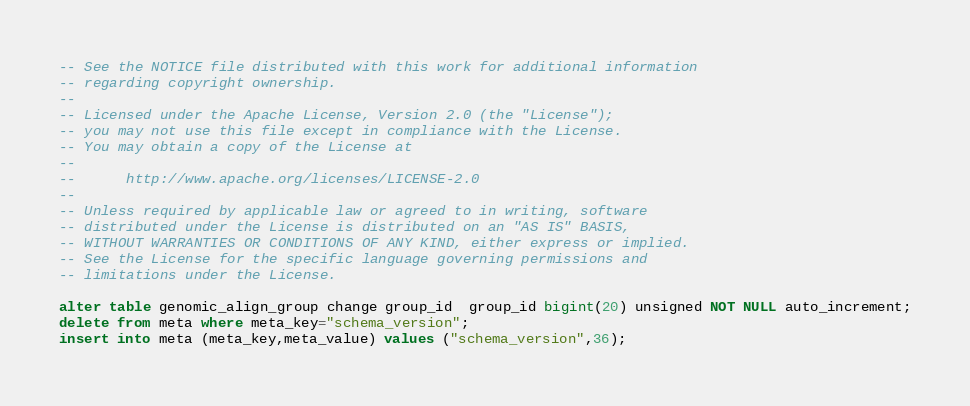Convert code to text. <code><loc_0><loc_0><loc_500><loc_500><_SQL_>-- See the NOTICE file distributed with this work for additional information
-- regarding copyright ownership.
-- 
-- Licensed under the Apache License, Version 2.0 (the "License");
-- you may not use this file except in compliance with the License.
-- You may obtain a copy of the License at
-- 
--      http://www.apache.org/licenses/LICENSE-2.0
-- 
-- Unless required by applicable law or agreed to in writing, software
-- distributed under the License is distributed on an "AS IS" BASIS,
-- WITHOUT WARRANTIES OR CONDITIONS OF ANY KIND, either express or implied.
-- See the License for the specific language governing permissions and
-- limitations under the License.

alter table genomic_align_group change group_id  group_id bigint(20) unsigned NOT NULL auto_increment;
delete from meta where meta_key="schema_version";
insert into meta (meta_key,meta_value) values ("schema_version",36);
</code> 